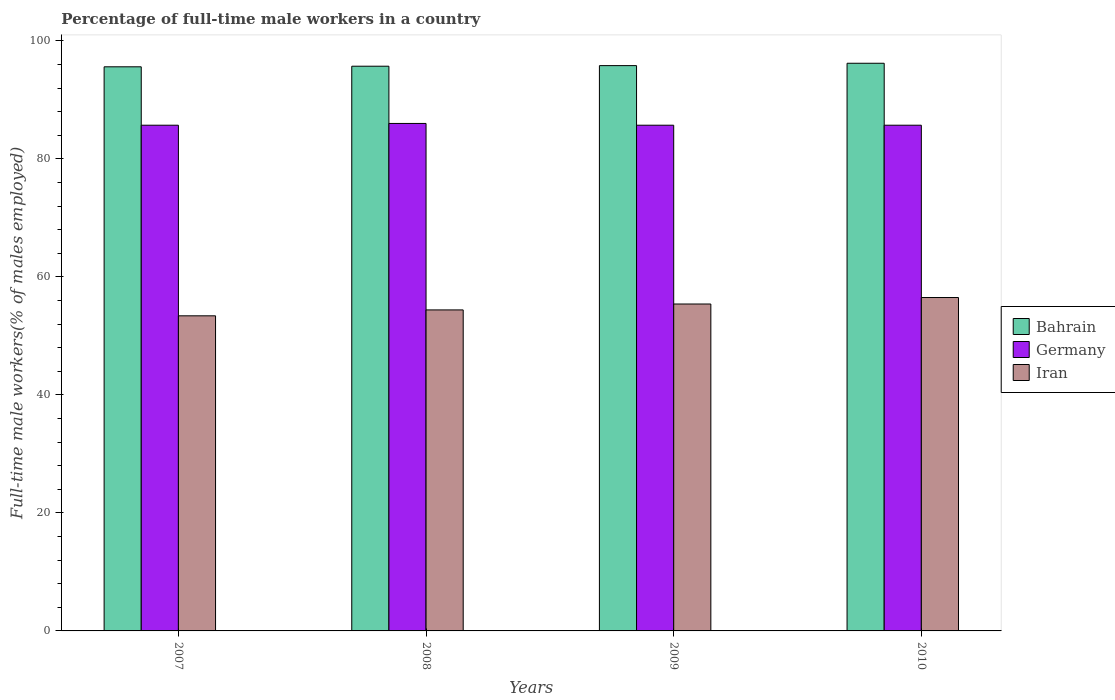How many groups of bars are there?
Provide a succinct answer. 4. Are the number of bars per tick equal to the number of legend labels?
Ensure brevity in your answer.  Yes. Are the number of bars on each tick of the X-axis equal?
Your answer should be very brief. Yes. How many bars are there on the 4th tick from the left?
Give a very brief answer. 3. How many bars are there on the 3rd tick from the right?
Your answer should be very brief. 3. What is the label of the 1st group of bars from the left?
Ensure brevity in your answer.  2007. What is the percentage of full-time male workers in Iran in 2009?
Provide a short and direct response. 55.4. Across all years, what is the maximum percentage of full-time male workers in Bahrain?
Your answer should be compact. 96.2. Across all years, what is the minimum percentage of full-time male workers in Iran?
Make the answer very short. 53.4. In which year was the percentage of full-time male workers in Bahrain maximum?
Offer a terse response. 2010. In which year was the percentage of full-time male workers in Iran minimum?
Ensure brevity in your answer.  2007. What is the total percentage of full-time male workers in Bahrain in the graph?
Give a very brief answer. 383.3. What is the difference between the percentage of full-time male workers in Bahrain in 2007 and the percentage of full-time male workers in Germany in 2009?
Offer a very short reply. 9.9. What is the average percentage of full-time male workers in Iran per year?
Offer a terse response. 54.93. In the year 2010, what is the difference between the percentage of full-time male workers in Bahrain and percentage of full-time male workers in Germany?
Keep it short and to the point. 10.5. In how many years, is the percentage of full-time male workers in Germany greater than 20 %?
Ensure brevity in your answer.  4. What is the ratio of the percentage of full-time male workers in Germany in 2007 to that in 2009?
Give a very brief answer. 1. Is the difference between the percentage of full-time male workers in Bahrain in 2008 and 2009 greater than the difference between the percentage of full-time male workers in Germany in 2008 and 2009?
Make the answer very short. No. What is the difference between the highest and the second highest percentage of full-time male workers in Iran?
Your answer should be very brief. 1.1. What is the difference between the highest and the lowest percentage of full-time male workers in Iran?
Ensure brevity in your answer.  3.1. In how many years, is the percentage of full-time male workers in Bahrain greater than the average percentage of full-time male workers in Bahrain taken over all years?
Offer a very short reply. 1. What does the 1st bar from the right in 2007 represents?
Your answer should be compact. Iran. Is it the case that in every year, the sum of the percentage of full-time male workers in Bahrain and percentage of full-time male workers in Iran is greater than the percentage of full-time male workers in Germany?
Offer a very short reply. Yes. How many bars are there?
Make the answer very short. 12. Where does the legend appear in the graph?
Provide a succinct answer. Center right. How are the legend labels stacked?
Offer a very short reply. Vertical. What is the title of the graph?
Provide a short and direct response. Percentage of full-time male workers in a country. Does "Northern Mariana Islands" appear as one of the legend labels in the graph?
Ensure brevity in your answer.  No. What is the label or title of the X-axis?
Give a very brief answer. Years. What is the label or title of the Y-axis?
Provide a short and direct response. Full-time male workers(% of males employed). What is the Full-time male workers(% of males employed) in Bahrain in 2007?
Ensure brevity in your answer.  95.6. What is the Full-time male workers(% of males employed) in Germany in 2007?
Your response must be concise. 85.7. What is the Full-time male workers(% of males employed) of Iran in 2007?
Ensure brevity in your answer.  53.4. What is the Full-time male workers(% of males employed) in Bahrain in 2008?
Give a very brief answer. 95.7. What is the Full-time male workers(% of males employed) in Germany in 2008?
Your answer should be very brief. 86. What is the Full-time male workers(% of males employed) in Iran in 2008?
Give a very brief answer. 54.4. What is the Full-time male workers(% of males employed) of Bahrain in 2009?
Make the answer very short. 95.8. What is the Full-time male workers(% of males employed) of Germany in 2009?
Ensure brevity in your answer.  85.7. What is the Full-time male workers(% of males employed) of Iran in 2009?
Offer a very short reply. 55.4. What is the Full-time male workers(% of males employed) in Bahrain in 2010?
Make the answer very short. 96.2. What is the Full-time male workers(% of males employed) of Germany in 2010?
Make the answer very short. 85.7. What is the Full-time male workers(% of males employed) in Iran in 2010?
Offer a terse response. 56.5. Across all years, what is the maximum Full-time male workers(% of males employed) of Bahrain?
Your answer should be very brief. 96.2. Across all years, what is the maximum Full-time male workers(% of males employed) in Iran?
Provide a short and direct response. 56.5. Across all years, what is the minimum Full-time male workers(% of males employed) of Bahrain?
Offer a terse response. 95.6. Across all years, what is the minimum Full-time male workers(% of males employed) of Germany?
Keep it short and to the point. 85.7. Across all years, what is the minimum Full-time male workers(% of males employed) of Iran?
Offer a terse response. 53.4. What is the total Full-time male workers(% of males employed) in Bahrain in the graph?
Give a very brief answer. 383.3. What is the total Full-time male workers(% of males employed) of Germany in the graph?
Provide a short and direct response. 343.1. What is the total Full-time male workers(% of males employed) of Iran in the graph?
Your response must be concise. 219.7. What is the difference between the Full-time male workers(% of males employed) in Bahrain in 2007 and that in 2008?
Ensure brevity in your answer.  -0.1. What is the difference between the Full-time male workers(% of males employed) of Germany in 2007 and that in 2009?
Your response must be concise. 0. What is the difference between the Full-time male workers(% of males employed) of Germany in 2007 and that in 2010?
Offer a very short reply. 0. What is the difference between the Full-time male workers(% of males employed) in Bahrain in 2008 and that in 2009?
Your response must be concise. -0.1. What is the difference between the Full-time male workers(% of males employed) of Germany in 2008 and that in 2009?
Ensure brevity in your answer.  0.3. What is the difference between the Full-time male workers(% of males employed) in Iran in 2008 and that in 2009?
Provide a short and direct response. -1. What is the difference between the Full-time male workers(% of males employed) in Germany in 2008 and that in 2010?
Keep it short and to the point. 0.3. What is the difference between the Full-time male workers(% of males employed) in Iran in 2008 and that in 2010?
Provide a short and direct response. -2.1. What is the difference between the Full-time male workers(% of males employed) of Bahrain in 2009 and that in 2010?
Ensure brevity in your answer.  -0.4. What is the difference between the Full-time male workers(% of males employed) in Germany in 2009 and that in 2010?
Provide a succinct answer. 0. What is the difference between the Full-time male workers(% of males employed) in Bahrain in 2007 and the Full-time male workers(% of males employed) in Iran in 2008?
Your answer should be compact. 41.2. What is the difference between the Full-time male workers(% of males employed) in Germany in 2007 and the Full-time male workers(% of males employed) in Iran in 2008?
Ensure brevity in your answer.  31.3. What is the difference between the Full-time male workers(% of males employed) of Bahrain in 2007 and the Full-time male workers(% of males employed) of Iran in 2009?
Offer a terse response. 40.2. What is the difference between the Full-time male workers(% of males employed) of Germany in 2007 and the Full-time male workers(% of males employed) of Iran in 2009?
Ensure brevity in your answer.  30.3. What is the difference between the Full-time male workers(% of males employed) in Bahrain in 2007 and the Full-time male workers(% of males employed) in Iran in 2010?
Your answer should be compact. 39.1. What is the difference between the Full-time male workers(% of males employed) in Germany in 2007 and the Full-time male workers(% of males employed) in Iran in 2010?
Ensure brevity in your answer.  29.2. What is the difference between the Full-time male workers(% of males employed) of Bahrain in 2008 and the Full-time male workers(% of males employed) of Germany in 2009?
Provide a succinct answer. 10. What is the difference between the Full-time male workers(% of males employed) in Bahrain in 2008 and the Full-time male workers(% of males employed) in Iran in 2009?
Your answer should be very brief. 40.3. What is the difference between the Full-time male workers(% of males employed) of Germany in 2008 and the Full-time male workers(% of males employed) of Iran in 2009?
Offer a very short reply. 30.6. What is the difference between the Full-time male workers(% of males employed) in Bahrain in 2008 and the Full-time male workers(% of males employed) in Germany in 2010?
Your answer should be very brief. 10. What is the difference between the Full-time male workers(% of males employed) in Bahrain in 2008 and the Full-time male workers(% of males employed) in Iran in 2010?
Make the answer very short. 39.2. What is the difference between the Full-time male workers(% of males employed) of Germany in 2008 and the Full-time male workers(% of males employed) of Iran in 2010?
Offer a terse response. 29.5. What is the difference between the Full-time male workers(% of males employed) of Bahrain in 2009 and the Full-time male workers(% of males employed) of Germany in 2010?
Provide a short and direct response. 10.1. What is the difference between the Full-time male workers(% of males employed) of Bahrain in 2009 and the Full-time male workers(% of males employed) of Iran in 2010?
Offer a very short reply. 39.3. What is the difference between the Full-time male workers(% of males employed) in Germany in 2009 and the Full-time male workers(% of males employed) in Iran in 2010?
Your response must be concise. 29.2. What is the average Full-time male workers(% of males employed) of Bahrain per year?
Provide a succinct answer. 95.83. What is the average Full-time male workers(% of males employed) of Germany per year?
Your answer should be very brief. 85.78. What is the average Full-time male workers(% of males employed) in Iran per year?
Your answer should be compact. 54.92. In the year 2007, what is the difference between the Full-time male workers(% of males employed) in Bahrain and Full-time male workers(% of males employed) in Iran?
Ensure brevity in your answer.  42.2. In the year 2007, what is the difference between the Full-time male workers(% of males employed) in Germany and Full-time male workers(% of males employed) in Iran?
Ensure brevity in your answer.  32.3. In the year 2008, what is the difference between the Full-time male workers(% of males employed) of Bahrain and Full-time male workers(% of males employed) of Germany?
Ensure brevity in your answer.  9.7. In the year 2008, what is the difference between the Full-time male workers(% of males employed) in Bahrain and Full-time male workers(% of males employed) in Iran?
Provide a succinct answer. 41.3. In the year 2008, what is the difference between the Full-time male workers(% of males employed) of Germany and Full-time male workers(% of males employed) of Iran?
Provide a short and direct response. 31.6. In the year 2009, what is the difference between the Full-time male workers(% of males employed) of Bahrain and Full-time male workers(% of males employed) of Germany?
Keep it short and to the point. 10.1. In the year 2009, what is the difference between the Full-time male workers(% of males employed) of Bahrain and Full-time male workers(% of males employed) of Iran?
Offer a very short reply. 40.4. In the year 2009, what is the difference between the Full-time male workers(% of males employed) in Germany and Full-time male workers(% of males employed) in Iran?
Offer a very short reply. 30.3. In the year 2010, what is the difference between the Full-time male workers(% of males employed) in Bahrain and Full-time male workers(% of males employed) in Iran?
Provide a short and direct response. 39.7. In the year 2010, what is the difference between the Full-time male workers(% of males employed) in Germany and Full-time male workers(% of males employed) in Iran?
Make the answer very short. 29.2. What is the ratio of the Full-time male workers(% of males employed) in Iran in 2007 to that in 2008?
Provide a succinct answer. 0.98. What is the ratio of the Full-time male workers(% of males employed) in Bahrain in 2007 to that in 2009?
Keep it short and to the point. 1. What is the ratio of the Full-time male workers(% of males employed) of Iran in 2007 to that in 2009?
Your answer should be compact. 0.96. What is the ratio of the Full-time male workers(% of males employed) in Iran in 2007 to that in 2010?
Provide a short and direct response. 0.95. What is the ratio of the Full-time male workers(% of males employed) of Bahrain in 2008 to that in 2009?
Your answer should be very brief. 1. What is the ratio of the Full-time male workers(% of males employed) of Germany in 2008 to that in 2009?
Offer a terse response. 1. What is the ratio of the Full-time male workers(% of males employed) of Iran in 2008 to that in 2009?
Your answer should be very brief. 0.98. What is the ratio of the Full-time male workers(% of males employed) in Bahrain in 2008 to that in 2010?
Keep it short and to the point. 0.99. What is the ratio of the Full-time male workers(% of males employed) of Iran in 2008 to that in 2010?
Ensure brevity in your answer.  0.96. What is the ratio of the Full-time male workers(% of males employed) of Germany in 2009 to that in 2010?
Ensure brevity in your answer.  1. What is the ratio of the Full-time male workers(% of males employed) in Iran in 2009 to that in 2010?
Offer a terse response. 0.98. What is the difference between the highest and the second highest Full-time male workers(% of males employed) of Bahrain?
Your response must be concise. 0.4. What is the difference between the highest and the second highest Full-time male workers(% of males employed) of Germany?
Ensure brevity in your answer.  0.3. What is the difference between the highest and the lowest Full-time male workers(% of males employed) in Bahrain?
Provide a succinct answer. 0.6. What is the difference between the highest and the lowest Full-time male workers(% of males employed) of Iran?
Offer a very short reply. 3.1. 